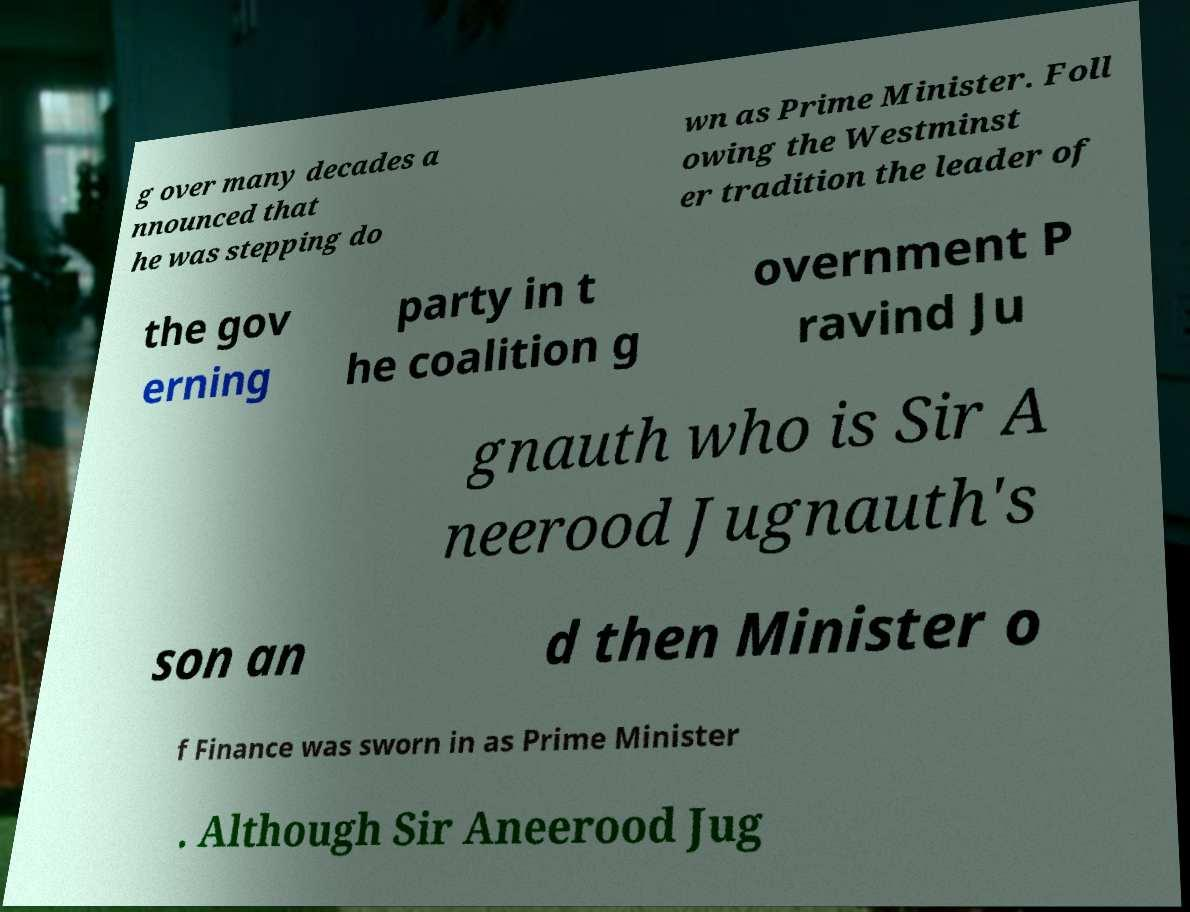Please identify and transcribe the text found in this image. g over many decades a nnounced that he was stepping do wn as Prime Minister. Foll owing the Westminst er tradition the leader of the gov erning party in t he coalition g overnment P ravind Ju gnauth who is Sir A neerood Jugnauth's son an d then Minister o f Finance was sworn in as Prime Minister . Although Sir Aneerood Jug 